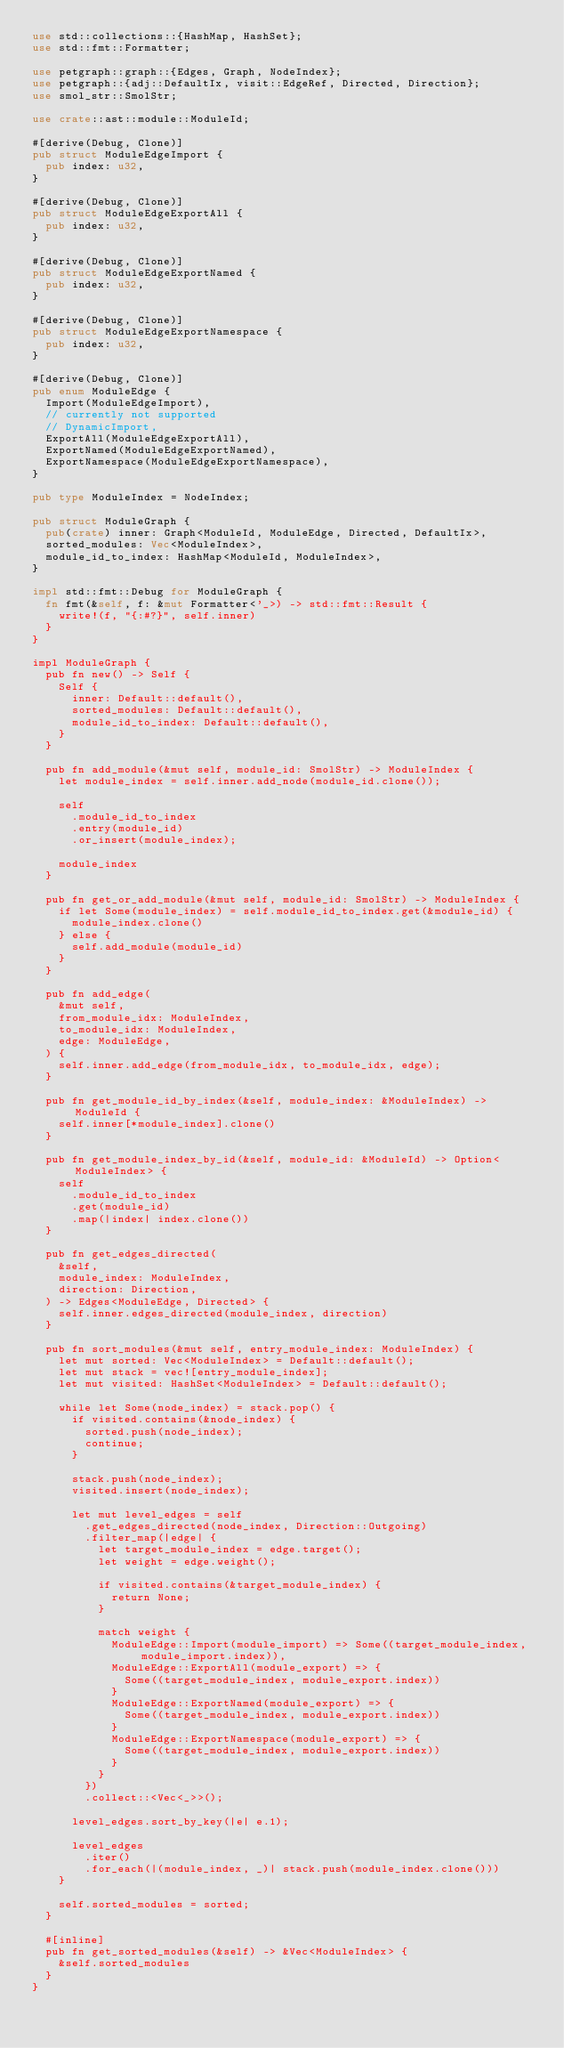Convert code to text. <code><loc_0><loc_0><loc_500><loc_500><_Rust_>use std::collections::{HashMap, HashSet};
use std::fmt::Formatter;

use petgraph::graph::{Edges, Graph, NodeIndex};
use petgraph::{adj::DefaultIx, visit::EdgeRef, Directed, Direction};
use smol_str::SmolStr;

use crate::ast::module::ModuleId;

#[derive(Debug, Clone)]
pub struct ModuleEdgeImport {
  pub index: u32,
}

#[derive(Debug, Clone)]
pub struct ModuleEdgeExportAll {
  pub index: u32,
}

#[derive(Debug, Clone)]
pub struct ModuleEdgeExportNamed {
  pub index: u32,
}

#[derive(Debug, Clone)]
pub struct ModuleEdgeExportNamespace {
  pub index: u32,
}

#[derive(Debug, Clone)]
pub enum ModuleEdge {
  Import(ModuleEdgeImport),
  // currently not supported
  // DynamicImport,
  ExportAll(ModuleEdgeExportAll),
  ExportNamed(ModuleEdgeExportNamed),
  ExportNamespace(ModuleEdgeExportNamespace),
}

pub type ModuleIndex = NodeIndex;

pub struct ModuleGraph {
  pub(crate) inner: Graph<ModuleId, ModuleEdge, Directed, DefaultIx>,
  sorted_modules: Vec<ModuleIndex>,
  module_id_to_index: HashMap<ModuleId, ModuleIndex>,
}

impl std::fmt::Debug for ModuleGraph {
  fn fmt(&self, f: &mut Formatter<'_>) -> std::fmt::Result {
    write!(f, "{:#?}", self.inner)
  }
}

impl ModuleGraph {
  pub fn new() -> Self {
    Self {
      inner: Default::default(),
      sorted_modules: Default::default(),
      module_id_to_index: Default::default(),
    }
  }

  pub fn add_module(&mut self, module_id: SmolStr) -> ModuleIndex {
    let module_index = self.inner.add_node(module_id.clone());

    self
      .module_id_to_index
      .entry(module_id)
      .or_insert(module_index);

    module_index
  }

  pub fn get_or_add_module(&mut self, module_id: SmolStr) -> ModuleIndex {
    if let Some(module_index) = self.module_id_to_index.get(&module_id) {
      module_index.clone()
    } else {
      self.add_module(module_id)
    }
  }

  pub fn add_edge(
    &mut self,
    from_module_idx: ModuleIndex,
    to_module_idx: ModuleIndex,
    edge: ModuleEdge,
  ) {
    self.inner.add_edge(from_module_idx, to_module_idx, edge);
  }

  pub fn get_module_id_by_index(&self, module_index: &ModuleIndex) -> ModuleId {
    self.inner[*module_index].clone()
  }

  pub fn get_module_index_by_id(&self, module_id: &ModuleId) -> Option<ModuleIndex> {
    self
      .module_id_to_index
      .get(module_id)
      .map(|index| index.clone())
  }

  pub fn get_edges_directed(
    &self,
    module_index: ModuleIndex,
    direction: Direction,
  ) -> Edges<ModuleEdge, Directed> {
    self.inner.edges_directed(module_index, direction)
  }

  pub fn sort_modules(&mut self, entry_module_index: ModuleIndex) {
    let mut sorted: Vec<ModuleIndex> = Default::default();
    let mut stack = vec![entry_module_index];
    let mut visited: HashSet<ModuleIndex> = Default::default();

    while let Some(node_index) = stack.pop() {
      if visited.contains(&node_index) {
        sorted.push(node_index);
        continue;
      }

      stack.push(node_index);
      visited.insert(node_index);

      let mut level_edges = self
        .get_edges_directed(node_index, Direction::Outgoing)
        .filter_map(|edge| {
          let target_module_index = edge.target();
          let weight = edge.weight();

          if visited.contains(&target_module_index) {
            return None;
          }

          match weight {
            ModuleEdge::Import(module_import) => Some((target_module_index, module_import.index)),
            ModuleEdge::ExportAll(module_export) => {
              Some((target_module_index, module_export.index))
            }
            ModuleEdge::ExportNamed(module_export) => {
              Some((target_module_index, module_export.index))
            }
            ModuleEdge::ExportNamespace(module_export) => {
              Some((target_module_index, module_export.index))
            }
          }
        })
        .collect::<Vec<_>>();

      level_edges.sort_by_key(|e| e.1);

      level_edges
        .iter()
        .for_each(|(module_index, _)| stack.push(module_index.clone()))
    }

    self.sorted_modules = sorted;
  }

  #[inline]
  pub fn get_sorted_modules(&self) -> &Vec<ModuleIndex> {
    &self.sorted_modules
  }
}
</code> 